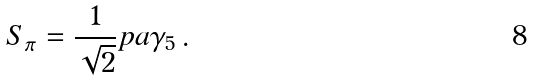<formula> <loc_0><loc_0><loc_500><loc_500>S _ { \pi } = \frac { 1 } { \sqrt { 2 } } p \sl a \gamma _ { 5 } \, .</formula> 